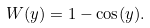<formula> <loc_0><loc_0><loc_500><loc_500>W ( y ) = 1 - \cos ( y ) .</formula> 